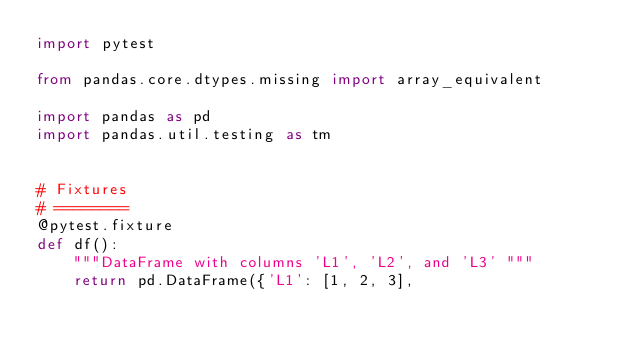<code> <loc_0><loc_0><loc_500><loc_500><_Python_>import pytest

from pandas.core.dtypes.missing import array_equivalent

import pandas as pd
import pandas.util.testing as tm


# Fixtures
# ========
@pytest.fixture
def df():
    """DataFrame with columns 'L1', 'L2', and 'L3' """
    return pd.DataFrame({'L1': [1, 2, 3],</code> 